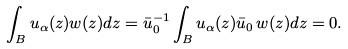<formula> <loc_0><loc_0><loc_500><loc_500>\int _ { B } u _ { \alpha } ( z ) w ( z ) d z = \bar { u } _ { 0 } ^ { - 1 } \int _ { B } u _ { \alpha } ( z ) \bar { u } _ { 0 } \, w ( z ) d z = 0 .</formula> 